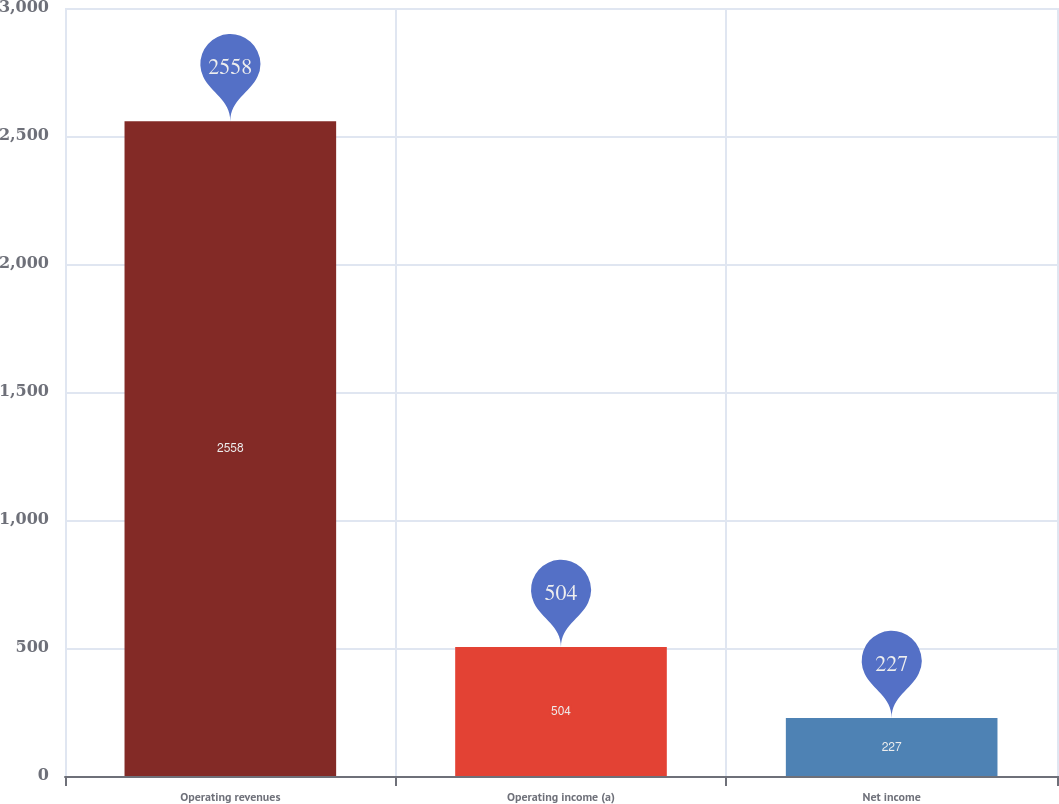<chart> <loc_0><loc_0><loc_500><loc_500><bar_chart><fcel>Operating revenues<fcel>Operating income (a)<fcel>Net income<nl><fcel>2558<fcel>504<fcel>227<nl></chart> 